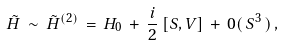Convert formula to latex. <formula><loc_0><loc_0><loc_500><loc_500>\tilde { H } \, \sim \, \tilde { H } ^ { ( 2 ) } \, = \, H _ { 0 } \, + \, \frac { i } { 2 } \, [ S , V ] \, + \, 0 ( \, S ^ { 3 } \, ) \, ,</formula> 